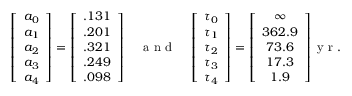Convert formula to latex. <formula><loc_0><loc_0><loc_500><loc_500>\left [ \begin{array} { c } { a _ { 0 } } \\ { a _ { 1 } } \\ { a _ { 2 } } \\ { a _ { 3 } } \\ { a _ { 4 } } \end{array} \right ] = \left [ \begin{array} { c } { . 1 3 1 } \\ { . 2 0 1 } \\ { . 3 2 1 } \\ { . 2 4 9 } \\ { . 0 9 8 } \end{array} \right ] \quad a n d \quad \left [ \begin{array} { c } { \tau _ { 0 } } \\ { \tau _ { 1 } } \\ { \tau _ { 2 } } \\ { \tau _ { 3 } } \\ { \tau _ { 4 } } \end{array} \right ] = \left [ \begin{array} { c } { \infty } \\ { 3 6 2 . 9 } \\ { 7 3 . 6 } \\ { 1 7 . 3 } \\ { 1 . 9 } \end{array} \right ] y r .</formula> 